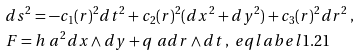<formula> <loc_0><loc_0><loc_500><loc_500>& d s ^ { 2 } = - c _ { 1 } ( r ) ^ { 2 } d t ^ { 2 } + c _ { 2 } ( r ) ^ { 2 } ( d x ^ { 2 } + d y ^ { 2 } ) + c _ { 3 } ( r ) ^ { 2 } d r ^ { 2 } \, , \\ & F = h \ a ^ { 2 } d x \wedge d y + q \ a d r \wedge d t \, , \ e q l a b e l { 1 . 2 1 }</formula> 